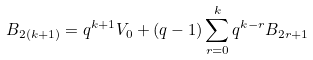Convert formula to latex. <formula><loc_0><loc_0><loc_500><loc_500>B _ { 2 ( k + 1 ) } = q ^ { k + 1 } V _ { 0 } + ( q - 1 ) \sum _ { r = 0 } ^ { k } q ^ { k - r } B _ { 2 r + 1 }</formula> 